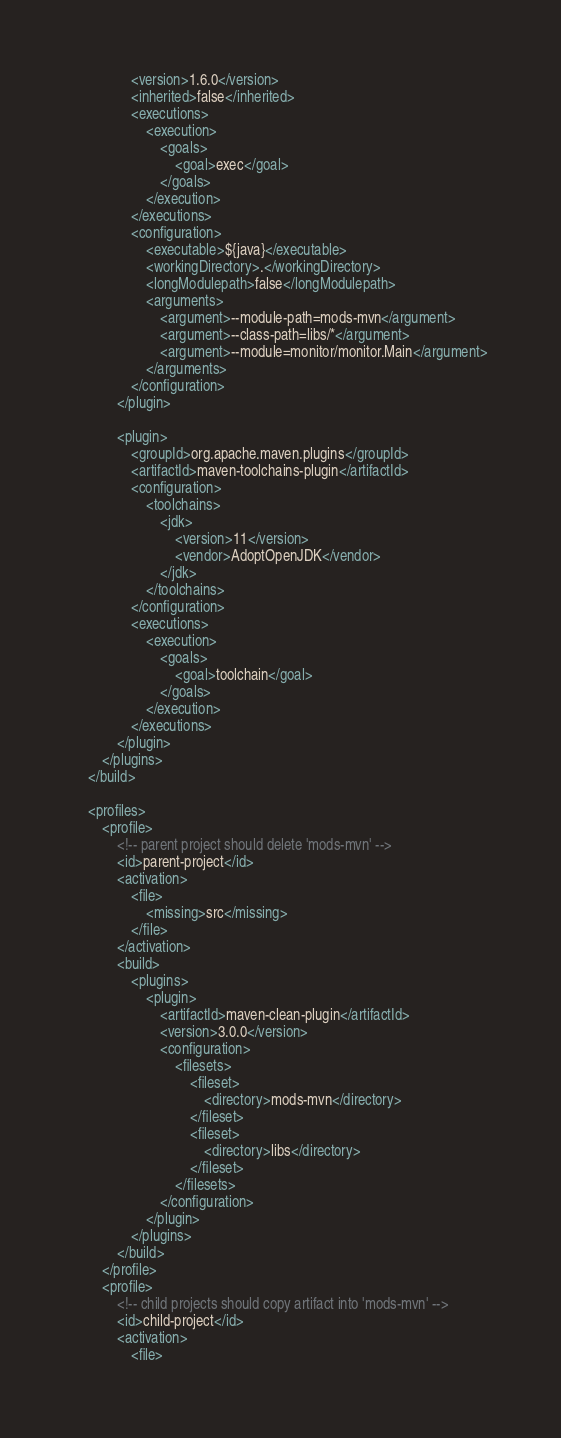<code> <loc_0><loc_0><loc_500><loc_500><_XML_>				<version>1.6.0</version>
				<inherited>false</inherited>
				<executions>
					<execution>
						<goals>
							<goal>exec</goal>
						</goals>
					</execution>
				</executions>
				<configuration>
					<executable>${java}</executable>
					<workingDirectory>.</workingDirectory>
					<longModulepath>false</longModulepath>
					<arguments>
						<argument>--module-path=mods-mvn</argument>
						<argument>--class-path=libs/*</argument>
						<argument>--module=monitor/monitor.Main</argument>
					</arguments>
				</configuration>
			</plugin>

			<plugin>
				<groupId>org.apache.maven.plugins</groupId>
				<artifactId>maven-toolchains-plugin</artifactId>
				<configuration>
					<toolchains>
						<jdk>
							<version>11</version>
							<vendor>AdoptOpenJDK</vendor>
						</jdk>
					</toolchains>
				</configuration>
				<executions>
					<execution>
						<goals>
							<goal>toolchain</goal>
						</goals>
					</execution>
				</executions>
			</plugin>
		</plugins>
	</build>

	<profiles>
		<profile>
			<!-- parent project should delete 'mods-mvn' -->
			<id>parent-project</id>
			<activation>
				<file>
					<missing>src</missing>
				</file>
			</activation>
			<build>
				<plugins>
					<plugin>
						<artifactId>maven-clean-plugin</artifactId>
						<version>3.0.0</version>
						<configuration>
							<filesets>
								<fileset>
									<directory>mods-mvn</directory>
								</fileset>
								<fileset>
									<directory>libs</directory>
								</fileset>
							</filesets>
						</configuration>
					</plugin>
				</plugins>
			</build>
		</profile>
		<profile>
			<!-- child projects should copy artifact into 'mods-mvn' -->
			<id>child-project</id>
			<activation>
				<file></code> 